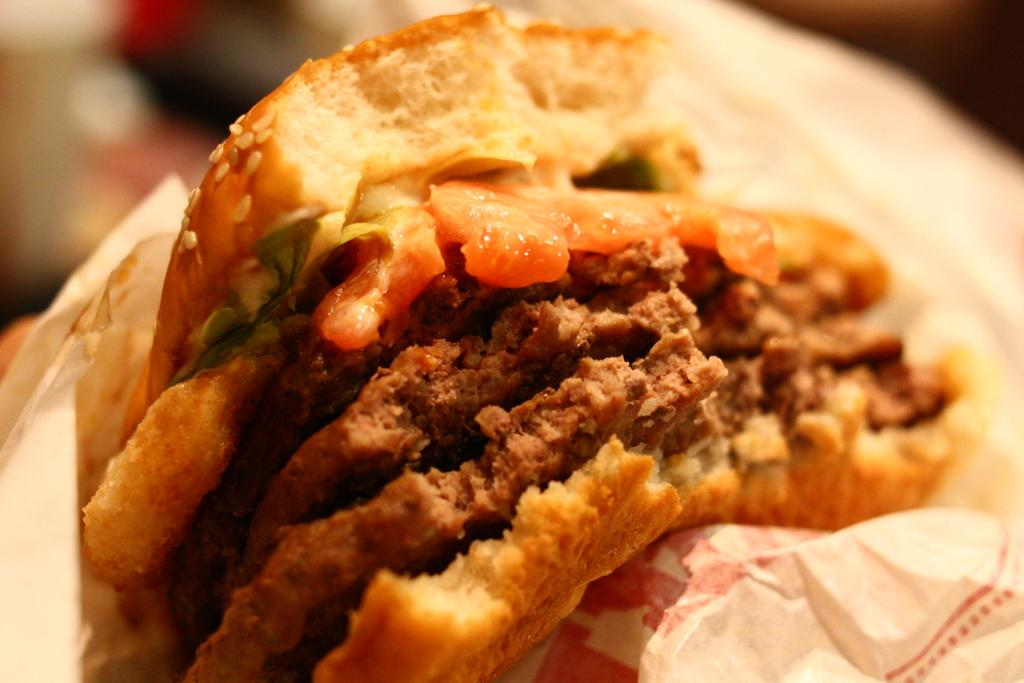What is the main object in the center of the image? There is a tissue paper in the center of the image. What else can be seen in the image besides the tissue paper? There is a food item in the image. What direction is the afterthought facing in the image? There is no afterthought present in the image, as it is not a physical object or person. 